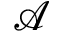<formula> <loc_0><loc_0><loc_500><loc_500>\mathcal { A }</formula> 